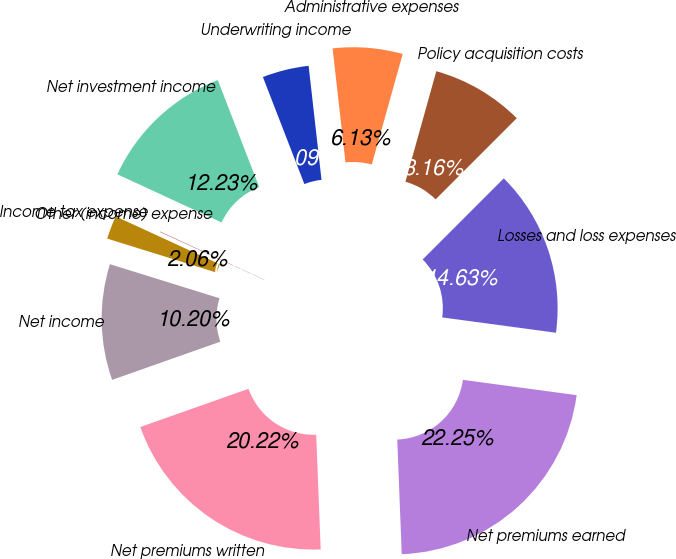Convert chart to OTSL. <chart><loc_0><loc_0><loc_500><loc_500><pie_chart><fcel>Net premiums written<fcel>Net premiums earned<fcel>Losses and loss expenses<fcel>Policy acquisition costs<fcel>Administrative expenses<fcel>Underwriting income<fcel>Net investment income<fcel>Other (income) expense<fcel>Income tax expense<fcel>Net income<nl><fcel>20.22%<fcel>22.25%<fcel>14.63%<fcel>8.16%<fcel>6.13%<fcel>4.09%<fcel>12.23%<fcel>0.03%<fcel>2.06%<fcel>10.2%<nl></chart> 